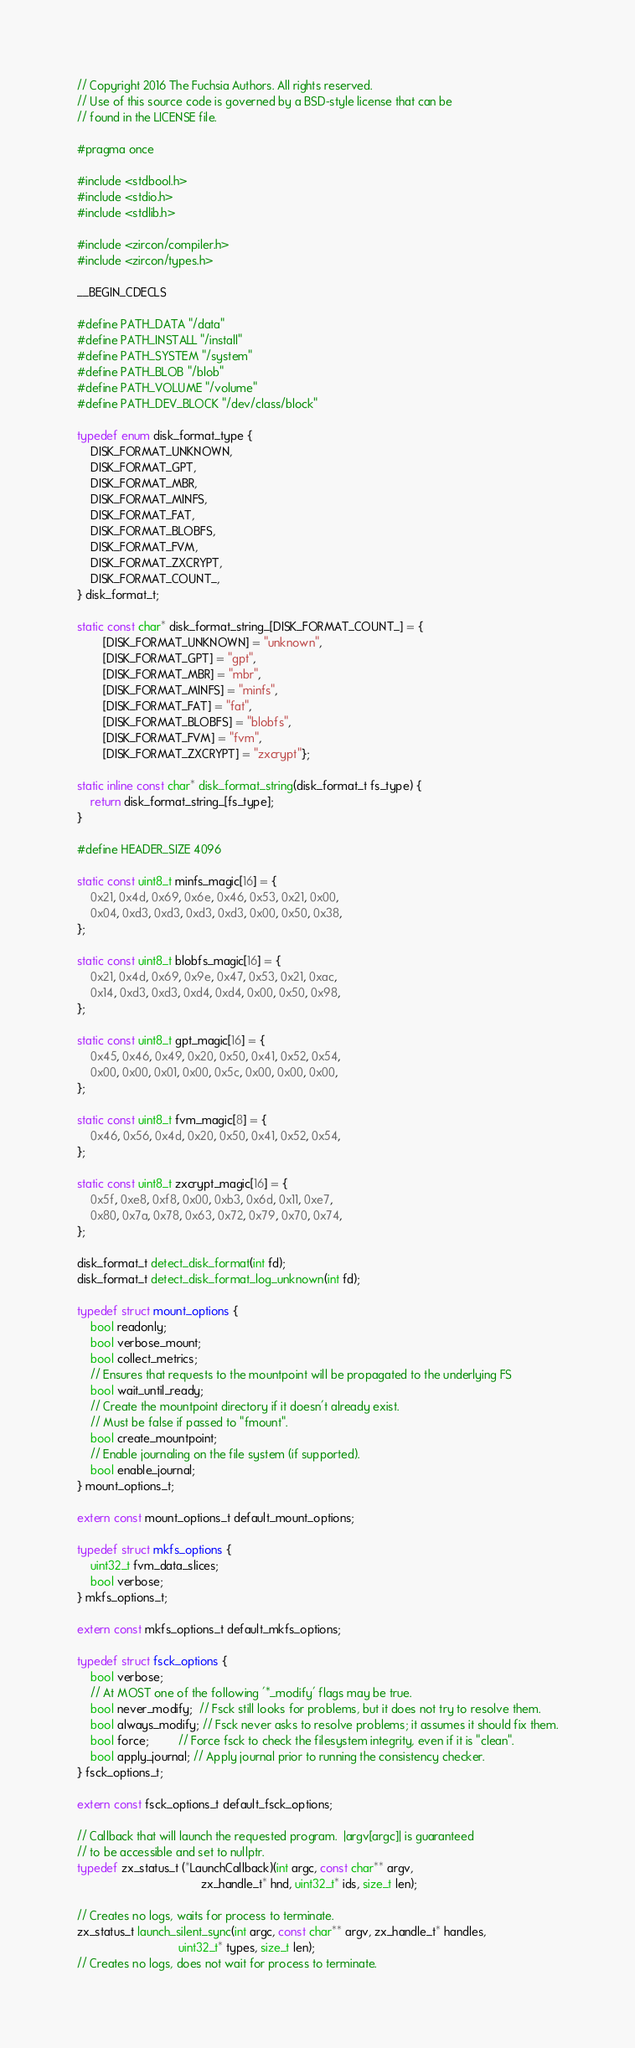<code> <loc_0><loc_0><loc_500><loc_500><_C_>// Copyright 2016 The Fuchsia Authors. All rights reserved.
// Use of this source code is governed by a BSD-style license that can be
// found in the LICENSE file.

#pragma once

#include <stdbool.h>
#include <stdio.h>
#include <stdlib.h>

#include <zircon/compiler.h>
#include <zircon/types.h>

__BEGIN_CDECLS

#define PATH_DATA "/data"
#define PATH_INSTALL "/install"
#define PATH_SYSTEM "/system"
#define PATH_BLOB "/blob"
#define PATH_VOLUME "/volume"
#define PATH_DEV_BLOCK "/dev/class/block"

typedef enum disk_format_type {
    DISK_FORMAT_UNKNOWN,
    DISK_FORMAT_GPT,
    DISK_FORMAT_MBR,
    DISK_FORMAT_MINFS,
    DISK_FORMAT_FAT,
    DISK_FORMAT_BLOBFS,
    DISK_FORMAT_FVM,
    DISK_FORMAT_ZXCRYPT,
    DISK_FORMAT_COUNT_,
} disk_format_t;

static const char* disk_format_string_[DISK_FORMAT_COUNT_] = {
        [DISK_FORMAT_UNKNOWN] = "unknown",
        [DISK_FORMAT_GPT] = "gpt",
        [DISK_FORMAT_MBR] = "mbr",
        [DISK_FORMAT_MINFS] = "minfs",
        [DISK_FORMAT_FAT] = "fat",
        [DISK_FORMAT_BLOBFS] = "blobfs",
        [DISK_FORMAT_FVM] = "fvm",
        [DISK_FORMAT_ZXCRYPT] = "zxcrypt"};

static inline const char* disk_format_string(disk_format_t fs_type) {
    return disk_format_string_[fs_type];
}

#define HEADER_SIZE 4096

static const uint8_t minfs_magic[16] = {
    0x21, 0x4d, 0x69, 0x6e, 0x46, 0x53, 0x21, 0x00,
    0x04, 0xd3, 0xd3, 0xd3, 0xd3, 0x00, 0x50, 0x38,
};

static const uint8_t blobfs_magic[16] = {
    0x21, 0x4d, 0x69, 0x9e, 0x47, 0x53, 0x21, 0xac,
    0x14, 0xd3, 0xd3, 0xd4, 0xd4, 0x00, 0x50, 0x98,
};

static const uint8_t gpt_magic[16] = {
    0x45, 0x46, 0x49, 0x20, 0x50, 0x41, 0x52, 0x54,
    0x00, 0x00, 0x01, 0x00, 0x5c, 0x00, 0x00, 0x00,
};

static const uint8_t fvm_magic[8] = {
    0x46, 0x56, 0x4d, 0x20, 0x50, 0x41, 0x52, 0x54,
};

static const uint8_t zxcrypt_magic[16] = {
    0x5f, 0xe8, 0xf8, 0x00, 0xb3, 0x6d, 0x11, 0xe7,
    0x80, 0x7a, 0x78, 0x63, 0x72, 0x79, 0x70, 0x74,
};

disk_format_t detect_disk_format(int fd);
disk_format_t detect_disk_format_log_unknown(int fd);

typedef struct mount_options {
    bool readonly;
    bool verbose_mount;
    bool collect_metrics;
    // Ensures that requests to the mountpoint will be propagated to the underlying FS
    bool wait_until_ready;
    // Create the mountpoint directory if it doesn't already exist.
    // Must be false if passed to "fmount".
    bool create_mountpoint;
    // Enable journaling on the file system (if supported).
    bool enable_journal;
} mount_options_t;

extern const mount_options_t default_mount_options;

typedef struct mkfs_options {
    uint32_t fvm_data_slices;
    bool verbose;
} mkfs_options_t;

extern const mkfs_options_t default_mkfs_options;

typedef struct fsck_options {
    bool verbose;
    // At MOST one of the following '*_modify' flags may be true.
    bool never_modify;  // Fsck still looks for problems, but it does not try to resolve them.
    bool always_modify; // Fsck never asks to resolve problems; it assumes it should fix them.
    bool force;         // Force fsck to check the filesystem integrity, even if it is "clean".
    bool apply_journal; // Apply journal prior to running the consistency checker.
} fsck_options_t;

extern const fsck_options_t default_fsck_options;

// Callback that will launch the requested program.  |argv[argc]| is guaranteed
// to be accessible and set to nullptr.
typedef zx_status_t (*LaunchCallback)(int argc, const char** argv,
                                      zx_handle_t* hnd, uint32_t* ids, size_t len);

// Creates no logs, waits for process to terminate.
zx_status_t launch_silent_sync(int argc, const char** argv, zx_handle_t* handles,
                               uint32_t* types, size_t len);
// Creates no logs, does not wait for process to terminate.</code> 